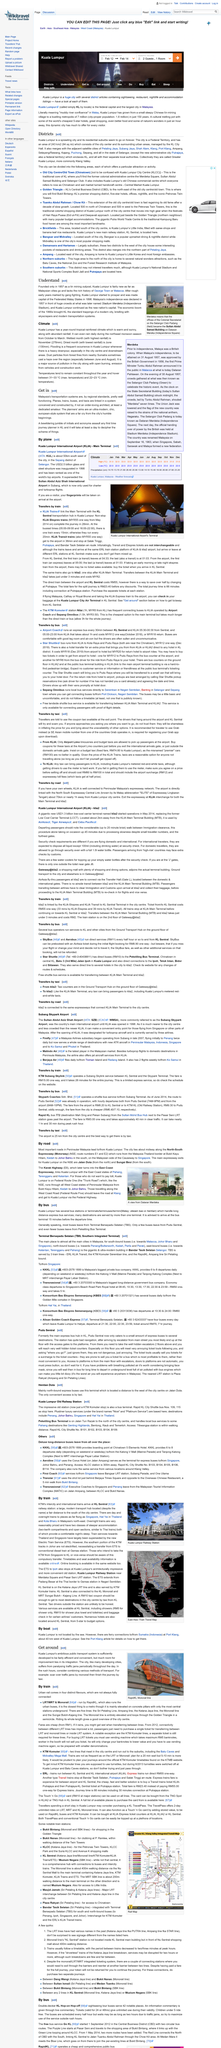Indicate a few pertinent items in this graphic. The above picture conveys the image of the RapidKL Monorail line, which is a transportation system that uses a monorail to travel along a track. Kuala Lumpur, once known for its tumultuous past marked by gang fighting, has come a long way to become a bustling metropolis. Kuala Lumpur can be reached by boat through the Port Klang ferry terminal, which is approximately 40 kilometers west of the city. KLIA Main Terminal is connected to the same expressways as klia2, which allows for seamless transportation between the two terminals. Terminal Bersepadu Selatan is a railway station located in Malaysia that serves the southern terminal of the Klang Valley Mass Rapid Transit (MRT) line. 